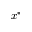<formula> <loc_0><loc_0><loc_500><loc_500>x ^ { * }</formula> 